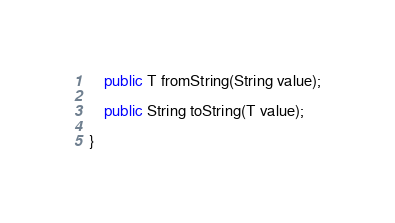Convert code to text. <code><loc_0><loc_0><loc_500><loc_500><_Java_>
    public T fromString(String value);

    public String toString(T value);

}
</code> 